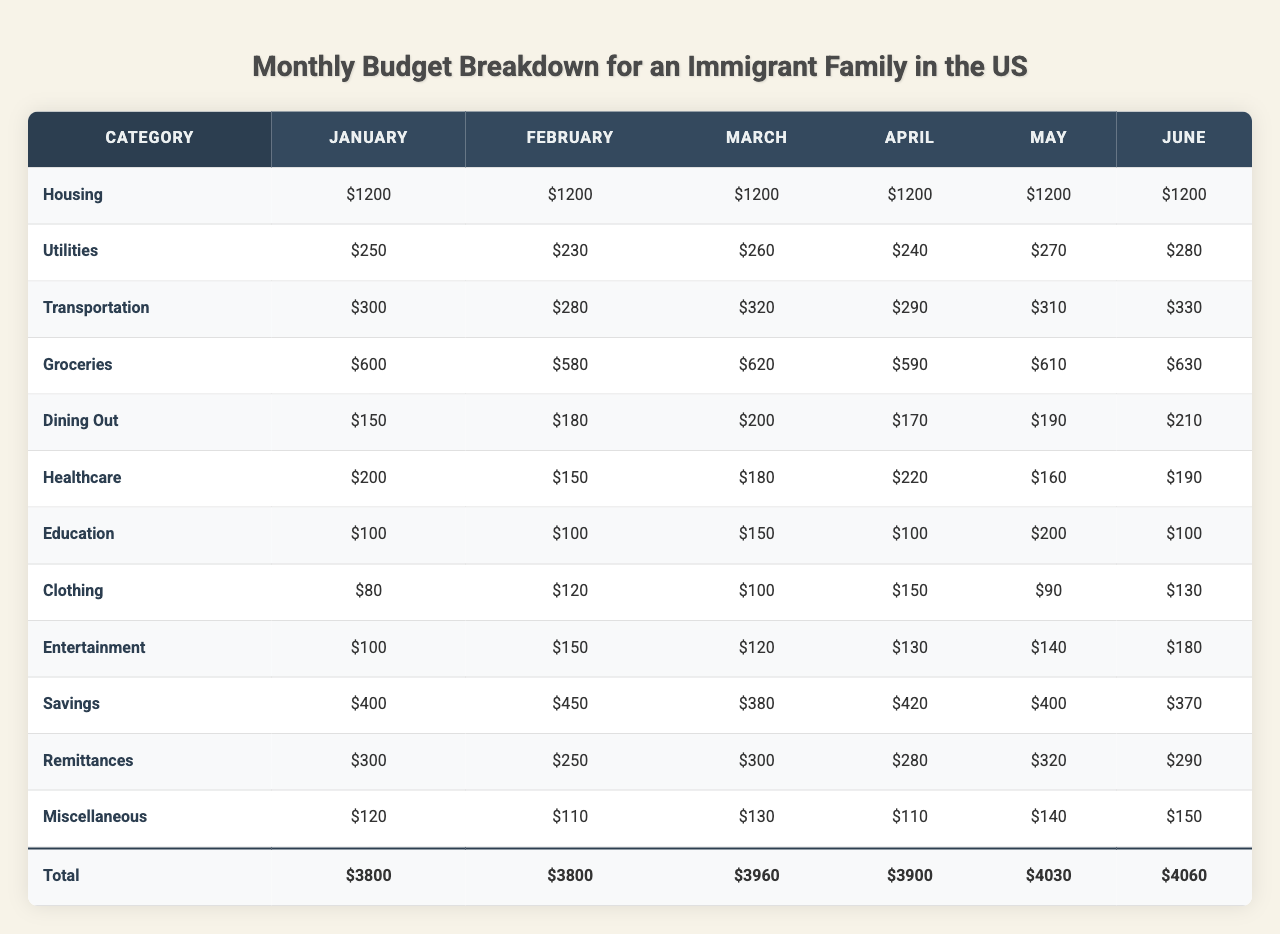What is the total expenditure for groceries in May? The expenditure in May for groceries is $610. There are no other values to consider since the question only asks for the specific month and category.
Answer: 610 What was the highest expense category in January? In January, the highest expense category is Housing at $1200. This can be seen by comparing all the values in that month.
Answer: Housing Is there an increase in transportation costs from February to March? February has transportation costs of $280, and March has costs of $320. Since $320 is greater than $280, there is an increase of $40.
Answer: Yes What is the average spent on healthcare from January to June? To find the average healthcare expenditure: (200 + 150 + 180 + 220 + 160 + 190) = 1100; dividing by 6 gives an average of 1100/6 ≈ 183.33.
Answer: Approximately 183.33 Which month had the lowest combined expenditure across all categories? By calculating the total for each month: January: 3300, February: 3030, March: 3090, April: 3020, May: 3130, June: 3030. The lowest is April at $3020.
Answer: April What are the total savings across all months? Total savings are calculated as follows: (400 + 450 + 380 + 420 + 400 + 370) = 2320. Therefore, total savings amount to $2320.
Answer: 2320 Did dining out expenses ever exceed $200? When examining the dining out expenses, January, February, March, April, May, and June show amounts of 150, 180, 200, 170, 190, and 210 respectively. June is the only month above $200.
Answer: Yes What is the total amount spent on clothing over the six months? Total spending on clothing is calculated as follows: (80 + 120 + 100 + 150 + 90 + 130) = 670. Therefore, the total is $670.
Answer: 670 How much more was spent on utilities in February compared to January? The utility costs in February are $230 and in January, they are $250. The difference reveals that $250 - $230 = $20 was spent less in February.
Answer: 20 less Which category shows the most fluctuation in expenses from month to month? To determine volatility, look at all the monthly values for a category. Transportation shows significant fluctuation: it ranges from $280 in February to $330 in June (an increase of $50) and has values that vary significantly.
Answer: Transportation What is the change in remittances from January to June? In January, remittance costs are $300, and in June, they are $290. The change is $300 - $290 = $10, showing a decrease.
Answer: Decrease of 10 When considering all months, which category has the highest average cost? To find the category with the highest average, sum each category's costs: Housing: 7200, Utilities: 1530, Transportation: 1800, etc. Housing has the highest average of $1200.
Answer: Housing Was there any month where healthcare costs were lower than $150? Reviewing healthcare expenses shows that in February, costs were $150, not lower, as all months stayed above $150.
Answer: No 